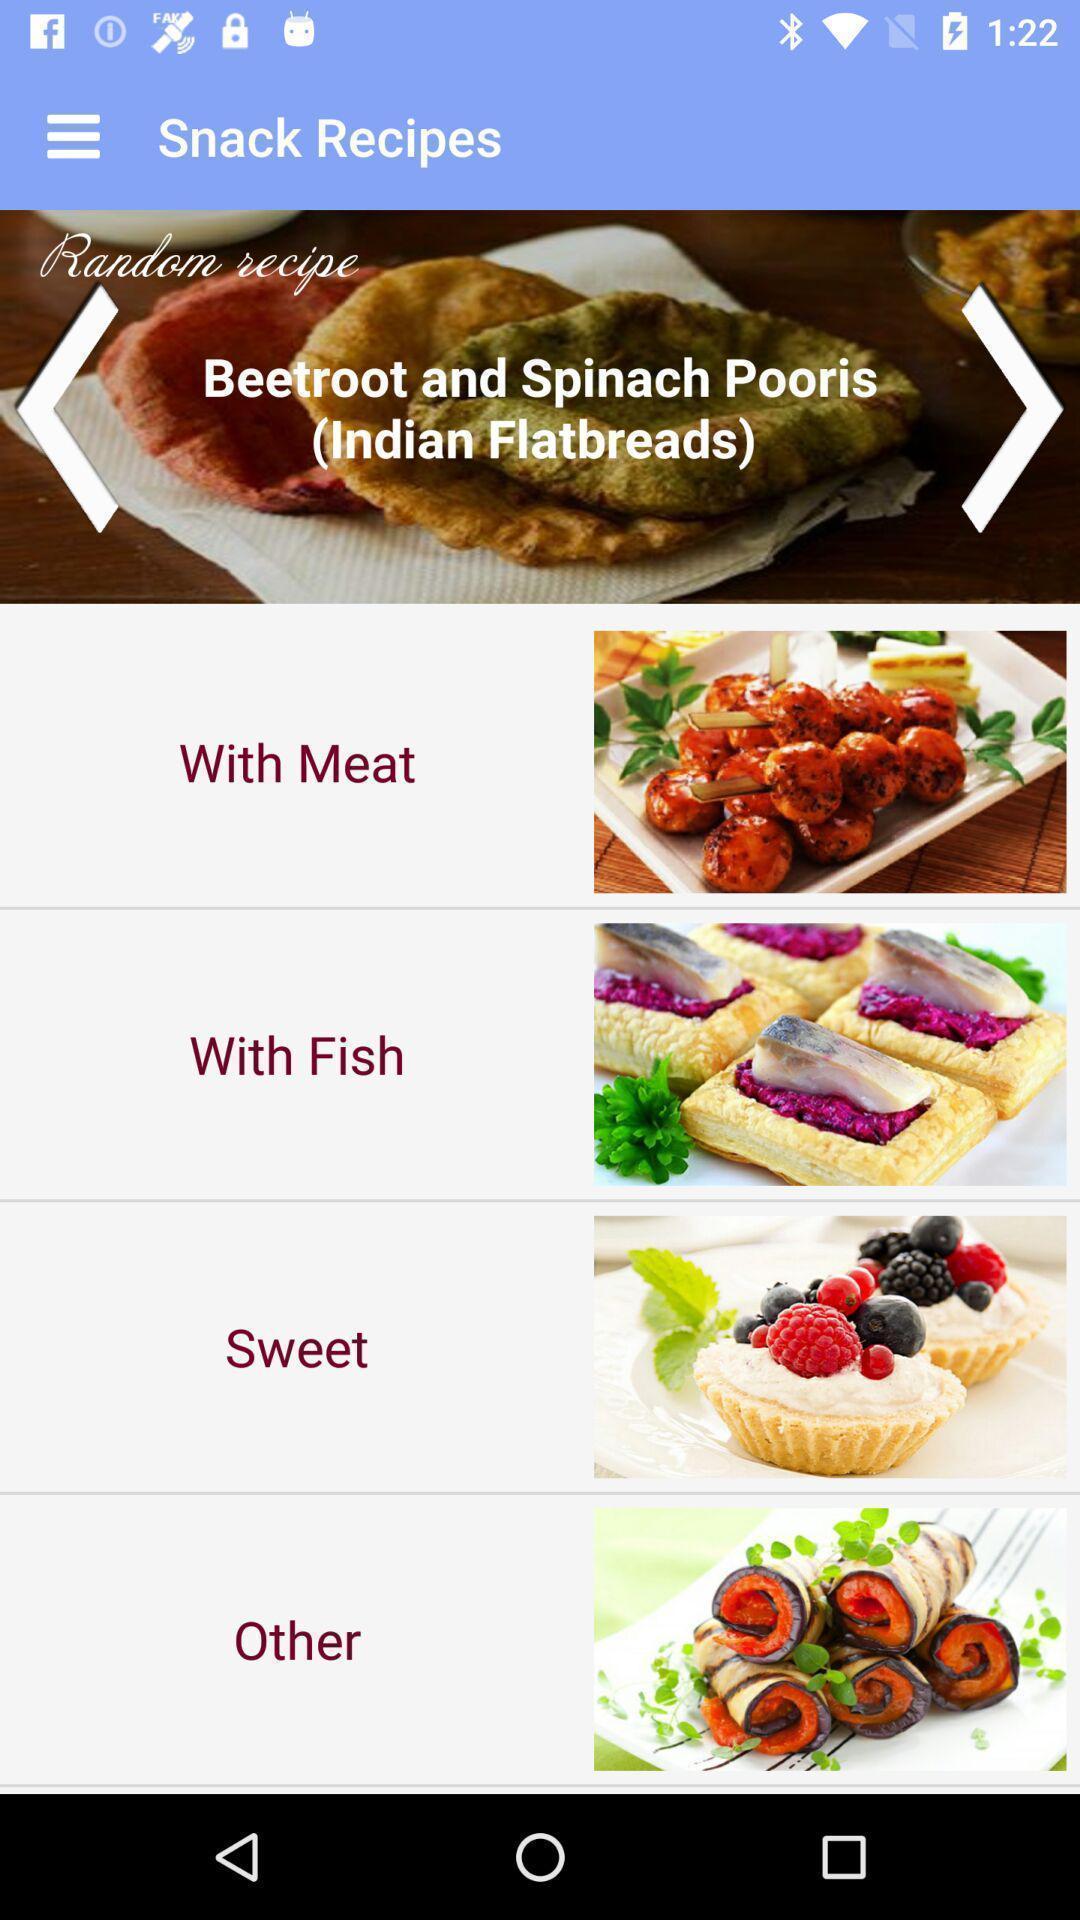Summarize the information in this screenshot. Screen shows various food recipes. 